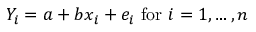Convert formula to latex. <formula><loc_0><loc_0><loc_500><loc_500>Y _ { i } = a + b x _ { i } + e _ { i } { f o r } i = 1 , \dots , n</formula> 